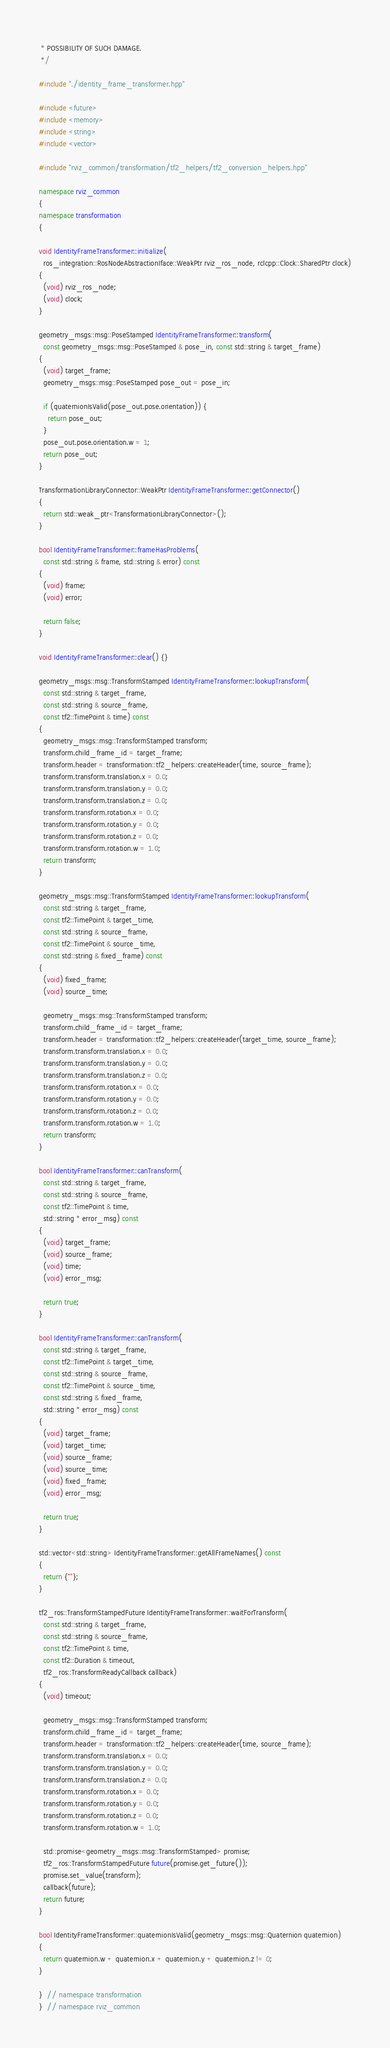Convert code to text. <code><loc_0><loc_0><loc_500><loc_500><_C++_> * POSSIBILITY OF SUCH DAMAGE.
 */

#include "./identity_frame_transformer.hpp"

#include <future>
#include <memory>
#include <string>
#include <vector>

#include "rviz_common/transformation/tf2_helpers/tf2_conversion_helpers.hpp"

namespace rviz_common
{
namespace transformation
{

void IdentityFrameTransformer::initialize(
  ros_integration::RosNodeAbstractionIface::WeakPtr rviz_ros_node, rclcpp::Clock::SharedPtr clock)
{
  (void) rviz_ros_node;
  (void) clock;
}

geometry_msgs::msg::PoseStamped IdentityFrameTransformer::transform(
  const geometry_msgs::msg::PoseStamped & pose_in, const std::string & target_frame)
{
  (void) target_frame;
  geometry_msgs::msg::PoseStamped pose_out = pose_in;

  if (quaternionIsValid(pose_out.pose.orientation)) {
    return pose_out;
  }
  pose_out.pose.orientation.w = 1;
  return pose_out;
}

TransformationLibraryConnector::WeakPtr IdentityFrameTransformer::getConnector()
{
  return std::weak_ptr<TransformationLibraryConnector>();
}

bool IdentityFrameTransformer::frameHasProblems(
  const std::string & frame, std::string & error) const
{
  (void) frame;
  (void) error;

  return false;
}

void IdentityFrameTransformer::clear() {}

geometry_msgs::msg::TransformStamped IdentityFrameTransformer::lookupTransform(
  const std::string & target_frame,
  const std::string & source_frame,
  const tf2::TimePoint & time) const
{
  geometry_msgs::msg::TransformStamped transform;
  transform.child_frame_id = target_frame;
  transform.header = transformation::tf2_helpers::createHeader(time, source_frame);
  transform.transform.translation.x = 0.0;
  transform.transform.translation.y = 0.0;
  transform.transform.translation.z = 0.0;
  transform.transform.rotation.x = 0.0;
  transform.transform.rotation.y = 0.0;
  transform.transform.rotation.z = 0.0;
  transform.transform.rotation.w = 1.0;
  return transform;
}

geometry_msgs::msg::TransformStamped IdentityFrameTransformer::lookupTransform(
  const std::string & target_frame,
  const tf2::TimePoint & target_time,
  const std::string & source_frame,
  const tf2::TimePoint & source_time,
  const std::string & fixed_frame) const
{
  (void) fixed_frame;
  (void) source_time;

  geometry_msgs::msg::TransformStamped transform;
  transform.child_frame_id = target_frame;
  transform.header = transformation::tf2_helpers::createHeader(target_time, source_frame);
  transform.transform.translation.x = 0.0;
  transform.transform.translation.y = 0.0;
  transform.transform.translation.z = 0.0;
  transform.transform.rotation.x = 0.0;
  transform.transform.rotation.y = 0.0;
  transform.transform.rotation.z = 0.0;
  transform.transform.rotation.w = 1.0;
  return transform;
}

bool IdentityFrameTransformer::canTransform(
  const std::string & target_frame,
  const std::string & source_frame,
  const tf2::TimePoint & time,
  std::string * error_msg) const
{
  (void) target_frame;
  (void) source_frame;
  (void) time;
  (void) error_msg;

  return true;
}

bool IdentityFrameTransformer::canTransform(
  const std::string & target_frame,
  const tf2::TimePoint & target_time,
  const std::string & source_frame,
  const tf2::TimePoint & source_time,
  const std::string & fixed_frame,
  std::string * error_msg) const
{
  (void) target_frame;
  (void) target_time;
  (void) source_frame;
  (void) source_time;
  (void) fixed_frame;
  (void) error_msg;

  return true;
}

std::vector<std::string> IdentityFrameTransformer::getAllFrameNames() const
{
  return {""};
}

tf2_ros::TransformStampedFuture IdentityFrameTransformer::waitForTransform(
  const std::string & target_frame,
  const std::string & source_frame,
  const tf2::TimePoint & time,
  const tf2::Duration & timeout,
  tf2_ros::TransformReadyCallback callback)
{
  (void) timeout;

  geometry_msgs::msg::TransformStamped transform;
  transform.child_frame_id = target_frame;
  transform.header = transformation::tf2_helpers::createHeader(time, source_frame);
  transform.transform.translation.x = 0.0;
  transform.transform.translation.y = 0.0;
  transform.transform.translation.z = 0.0;
  transform.transform.rotation.x = 0.0;
  transform.transform.rotation.y = 0.0;
  transform.transform.rotation.z = 0.0;
  transform.transform.rotation.w = 1.0;

  std::promise<geometry_msgs::msg::TransformStamped> promise;
  tf2_ros::TransformStampedFuture future(promise.get_future());
  promise.set_value(transform);
  callback(future);
  return future;
}

bool IdentityFrameTransformer::quaternionIsValid(geometry_msgs::msg::Quaternion quaternion)
{
  return quaternion.w + quaternion.x + quaternion.y + quaternion.z != 0;
}

}  // namespace transformation
}  // namespace rviz_common
</code> 